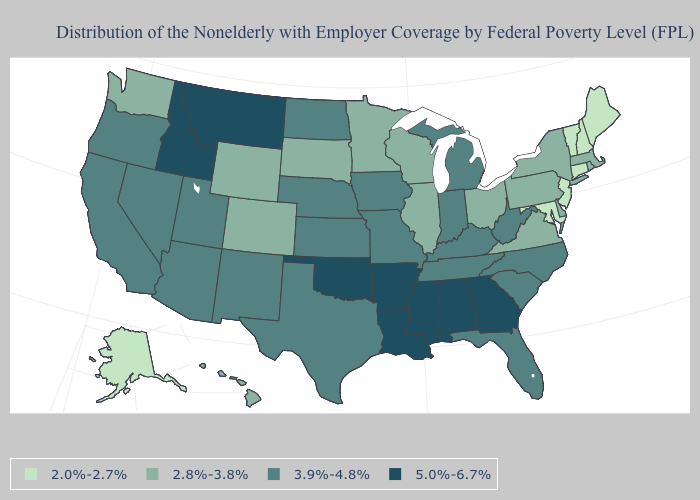Name the states that have a value in the range 2.8%-3.8%?
Quick response, please. Colorado, Delaware, Hawaii, Illinois, Massachusetts, Minnesota, New York, Ohio, Pennsylvania, Rhode Island, South Dakota, Virginia, Washington, Wisconsin, Wyoming. Which states hav the highest value in the West?
Short answer required. Idaho, Montana. What is the highest value in states that border New York?
Quick response, please. 2.8%-3.8%. Does New Hampshire have a lower value than Nebraska?
Be succinct. Yes. What is the value of Nevada?
Quick response, please. 3.9%-4.8%. Which states have the lowest value in the USA?
Write a very short answer. Alaska, Connecticut, Maine, Maryland, New Hampshire, New Jersey, Vermont. Does South Dakota have the same value as Minnesota?
Give a very brief answer. Yes. Among the states that border Massachusetts , which have the highest value?
Concise answer only. New York, Rhode Island. Is the legend a continuous bar?
Be succinct. No. What is the lowest value in states that border Alabama?
Answer briefly. 3.9%-4.8%. Is the legend a continuous bar?
Quick response, please. No. What is the value of Hawaii?
Short answer required. 2.8%-3.8%. What is the value of Washington?
Short answer required. 2.8%-3.8%. What is the value of North Carolina?
Short answer required. 3.9%-4.8%. Which states hav the highest value in the South?
Write a very short answer. Alabama, Arkansas, Georgia, Louisiana, Mississippi, Oklahoma. 